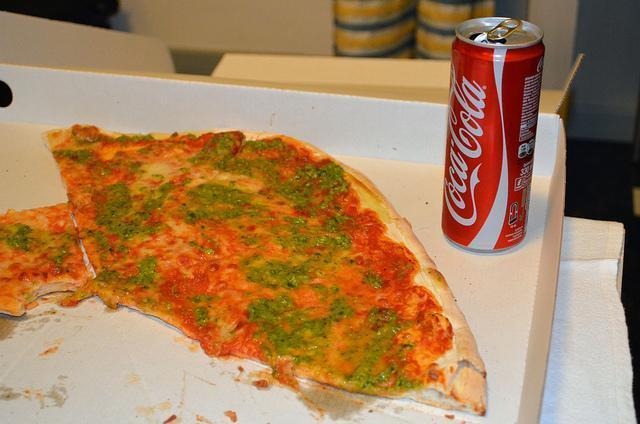How many glasses of beer is there?
Give a very brief answer. 0. How many pizzas can you see?
Give a very brief answer. 1. 